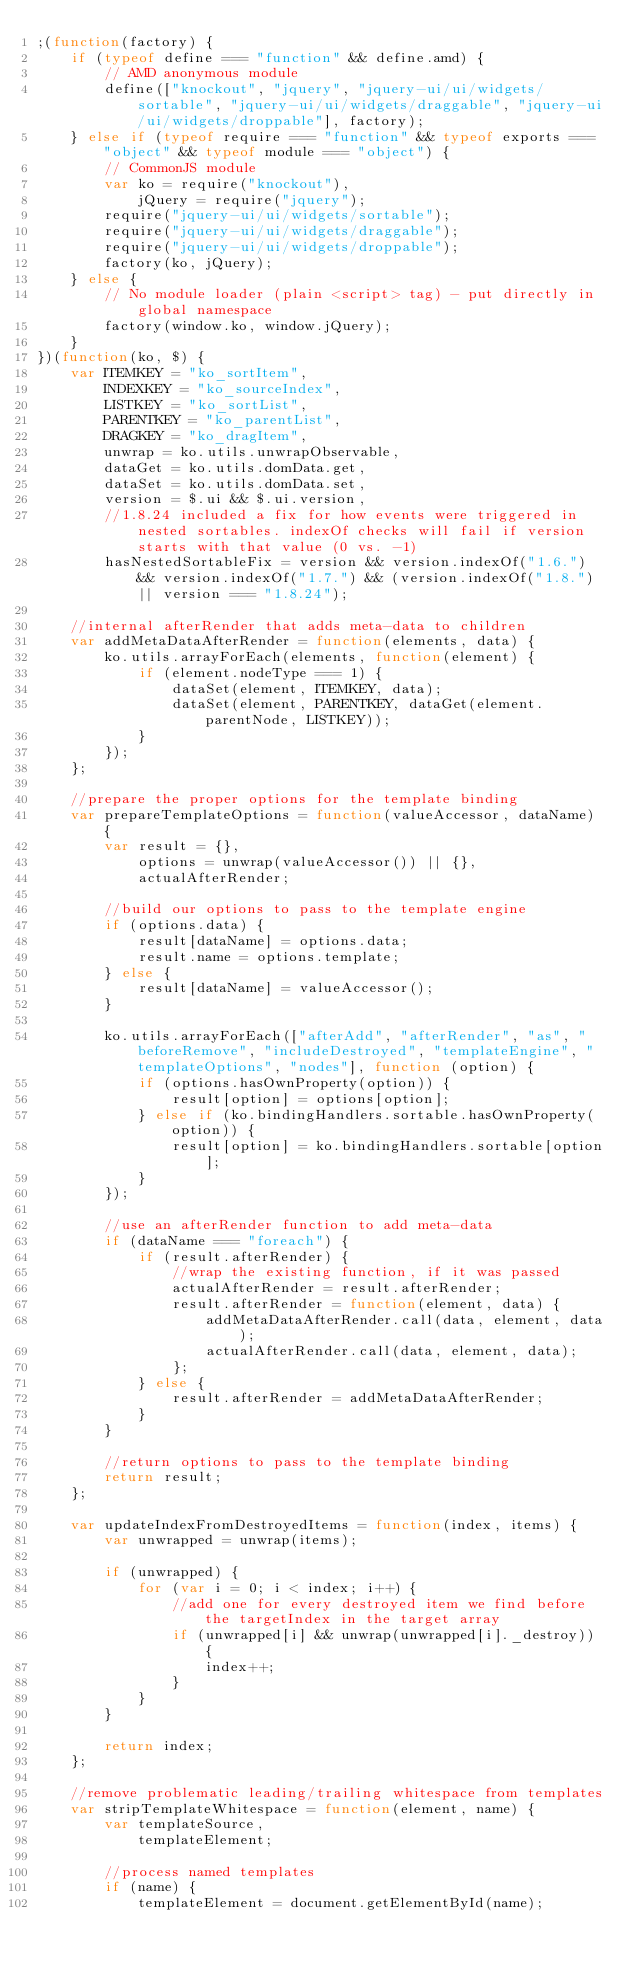Convert code to text. <code><loc_0><loc_0><loc_500><loc_500><_JavaScript_>;(function(factory) {
    if (typeof define === "function" && define.amd) {
        // AMD anonymous module
        define(["knockout", "jquery", "jquery-ui/ui/widgets/sortable", "jquery-ui/ui/widgets/draggable", "jquery-ui/ui/widgets/droppable"], factory);
    } else if (typeof require === "function" && typeof exports === "object" && typeof module === "object") {
        // CommonJS module
        var ko = require("knockout"),
            jQuery = require("jquery");
        require("jquery-ui/ui/widgets/sortable");
        require("jquery-ui/ui/widgets/draggable");
        require("jquery-ui/ui/widgets/droppable");
        factory(ko, jQuery);
    } else {
        // No module loader (plain <script> tag) - put directly in global namespace
        factory(window.ko, window.jQuery);
    }
})(function(ko, $) {
    var ITEMKEY = "ko_sortItem",
        INDEXKEY = "ko_sourceIndex",
        LISTKEY = "ko_sortList",
        PARENTKEY = "ko_parentList",
        DRAGKEY = "ko_dragItem",
        unwrap = ko.utils.unwrapObservable,
        dataGet = ko.utils.domData.get,
        dataSet = ko.utils.domData.set,
        version = $.ui && $.ui.version,
        //1.8.24 included a fix for how events were triggered in nested sortables. indexOf checks will fail if version starts with that value (0 vs. -1)
        hasNestedSortableFix = version && version.indexOf("1.6.") && version.indexOf("1.7.") && (version.indexOf("1.8.") || version === "1.8.24");

    //internal afterRender that adds meta-data to children
    var addMetaDataAfterRender = function(elements, data) {
        ko.utils.arrayForEach(elements, function(element) {
            if (element.nodeType === 1) {
                dataSet(element, ITEMKEY, data);
                dataSet(element, PARENTKEY, dataGet(element.parentNode, LISTKEY));
            }
        });
    };

    //prepare the proper options for the template binding
    var prepareTemplateOptions = function(valueAccessor, dataName) {
        var result = {},
            options = unwrap(valueAccessor()) || {},
            actualAfterRender;

        //build our options to pass to the template engine
        if (options.data) {
            result[dataName] = options.data;
            result.name = options.template;
        } else {
            result[dataName] = valueAccessor();
        }

        ko.utils.arrayForEach(["afterAdd", "afterRender", "as", "beforeRemove", "includeDestroyed", "templateEngine", "templateOptions", "nodes"], function (option) {
            if (options.hasOwnProperty(option)) {
                result[option] = options[option];
            } else if (ko.bindingHandlers.sortable.hasOwnProperty(option)) {
                result[option] = ko.bindingHandlers.sortable[option];
            }
        });

        //use an afterRender function to add meta-data
        if (dataName === "foreach") {
            if (result.afterRender) {
                //wrap the existing function, if it was passed
                actualAfterRender = result.afterRender;
                result.afterRender = function(element, data) {
                    addMetaDataAfterRender.call(data, element, data);
                    actualAfterRender.call(data, element, data);
                };
            } else {
                result.afterRender = addMetaDataAfterRender;
            }
        }

        //return options to pass to the template binding
        return result;
    };

    var updateIndexFromDestroyedItems = function(index, items) {
        var unwrapped = unwrap(items);

        if (unwrapped) {
            for (var i = 0; i < index; i++) {
                //add one for every destroyed item we find before the targetIndex in the target array
                if (unwrapped[i] && unwrap(unwrapped[i]._destroy)) {
                    index++;
                }
            }
        }

        return index;
    };

    //remove problematic leading/trailing whitespace from templates
    var stripTemplateWhitespace = function(element, name) {
        var templateSource,
            templateElement;

        //process named templates
        if (name) {
            templateElement = document.getElementById(name);</code> 